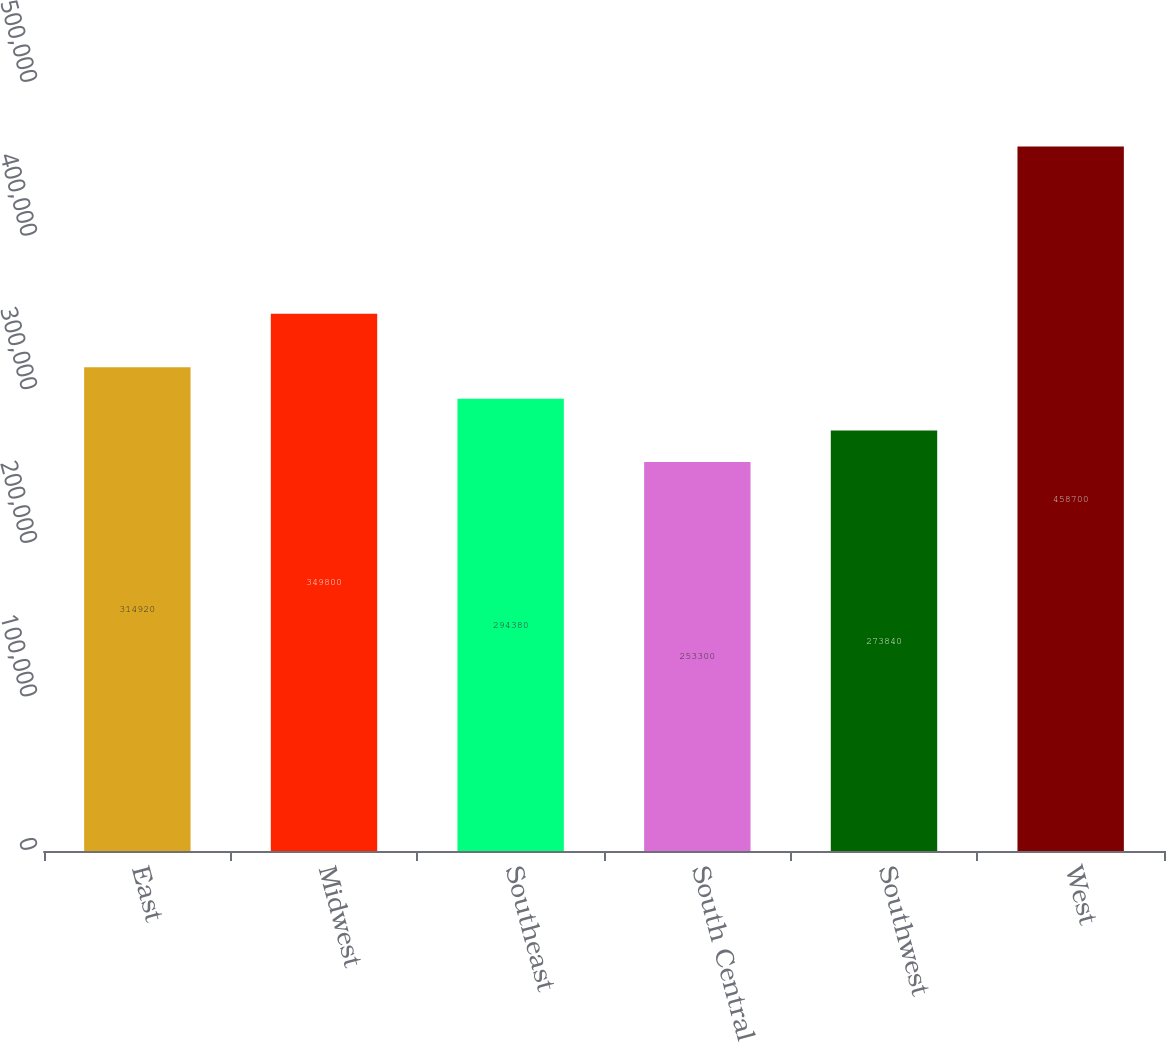<chart> <loc_0><loc_0><loc_500><loc_500><bar_chart><fcel>East<fcel>Midwest<fcel>Southeast<fcel>South Central<fcel>Southwest<fcel>West<nl><fcel>314920<fcel>349800<fcel>294380<fcel>253300<fcel>273840<fcel>458700<nl></chart> 